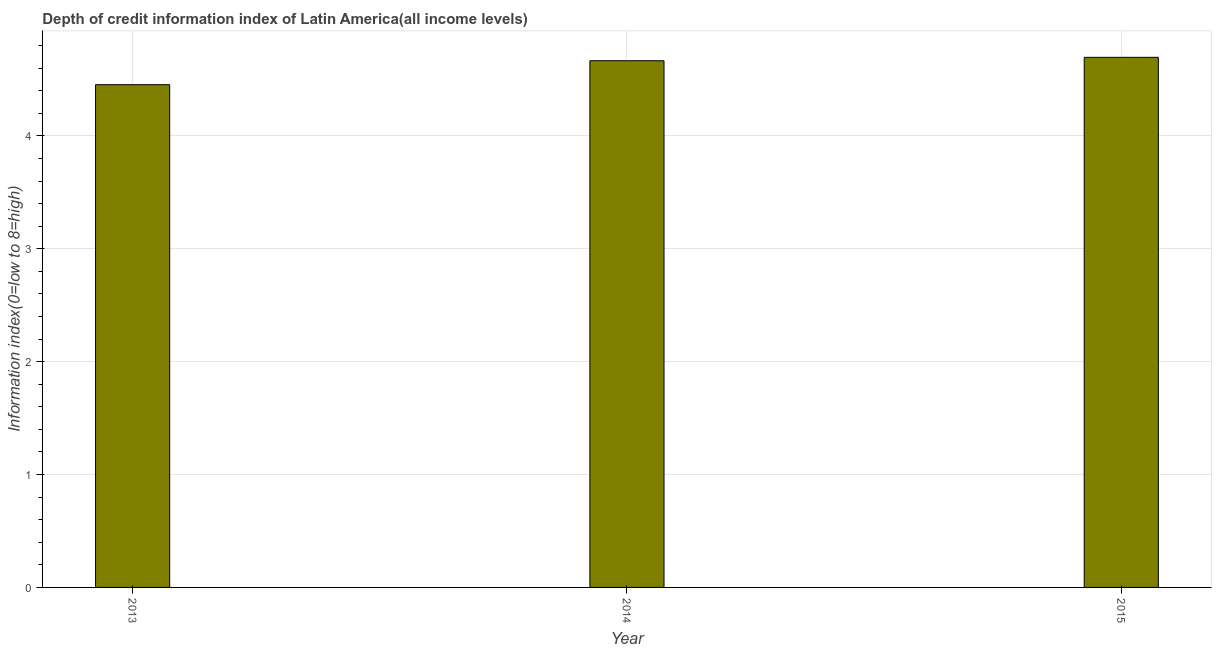Does the graph contain grids?
Provide a succinct answer. Yes. What is the title of the graph?
Keep it short and to the point. Depth of credit information index of Latin America(all income levels). What is the label or title of the X-axis?
Give a very brief answer. Year. What is the label or title of the Y-axis?
Provide a short and direct response. Information index(0=low to 8=high). What is the depth of credit information index in 2014?
Provide a succinct answer. 4.67. Across all years, what is the maximum depth of credit information index?
Offer a terse response. 4.7. Across all years, what is the minimum depth of credit information index?
Provide a succinct answer. 4.45. In which year was the depth of credit information index maximum?
Provide a succinct answer. 2015. In which year was the depth of credit information index minimum?
Keep it short and to the point. 2013. What is the sum of the depth of credit information index?
Provide a short and direct response. 13.82. What is the difference between the depth of credit information index in 2013 and 2015?
Your answer should be very brief. -0.24. What is the average depth of credit information index per year?
Give a very brief answer. 4.61. What is the median depth of credit information index?
Give a very brief answer. 4.67. What is the ratio of the depth of credit information index in 2013 to that in 2014?
Make the answer very short. 0.95. Is the difference between the depth of credit information index in 2013 and 2014 greater than the difference between any two years?
Ensure brevity in your answer.  No. What is the difference between the highest and the second highest depth of credit information index?
Offer a very short reply. 0.03. Is the sum of the depth of credit information index in 2013 and 2015 greater than the maximum depth of credit information index across all years?
Make the answer very short. Yes. What is the difference between the highest and the lowest depth of credit information index?
Your response must be concise. 0.24. Are all the bars in the graph horizontal?
Give a very brief answer. No. How many years are there in the graph?
Provide a short and direct response. 3. What is the Information index(0=low to 8=high) in 2013?
Provide a succinct answer. 4.45. What is the Information index(0=low to 8=high) of 2014?
Ensure brevity in your answer.  4.67. What is the Information index(0=low to 8=high) in 2015?
Your answer should be compact. 4.7. What is the difference between the Information index(0=low to 8=high) in 2013 and 2014?
Make the answer very short. -0.21. What is the difference between the Information index(0=low to 8=high) in 2013 and 2015?
Make the answer very short. -0.24. What is the difference between the Information index(0=low to 8=high) in 2014 and 2015?
Your response must be concise. -0.03. What is the ratio of the Information index(0=low to 8=high) in 2013 to that in 2014?
Provide a succinct answer. 0.95. What is the ratio of the Information index(0=low to 8=high) in 2013 to that in 2015?
Keep it short and to the point. 0.95. 